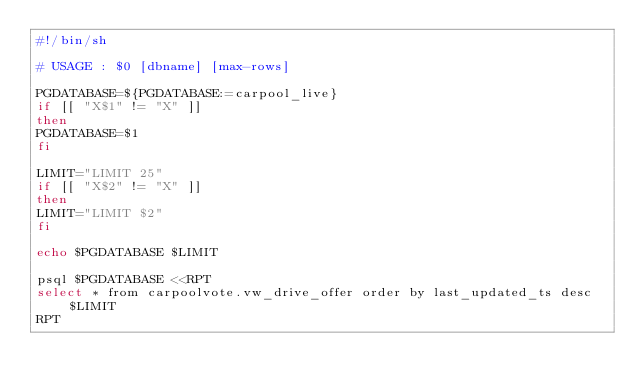<code> <loc_0><loc_0><loc_500><loc_500><_Bash_>#!/bin/sh

# USAGE : $0 [dbname] [max-rows]

PGDATABASE=${PGDATABASE:=carpool_live}
if [[ "X$1" != "X" ]]
then
PGDATABASE=$1
fi

LIMIT="LIMIT 25"
if [[ "X$2" != "X" ]]
then
LIMIT="LIMIT $2"
fi

echo $PGDATABASE $LIMIT

psql $PGDATABASE <<RPT
select * from carpoolvote.vw_drive_offer order by last_updated_ts desc $LIMIT
RPT


</code> 